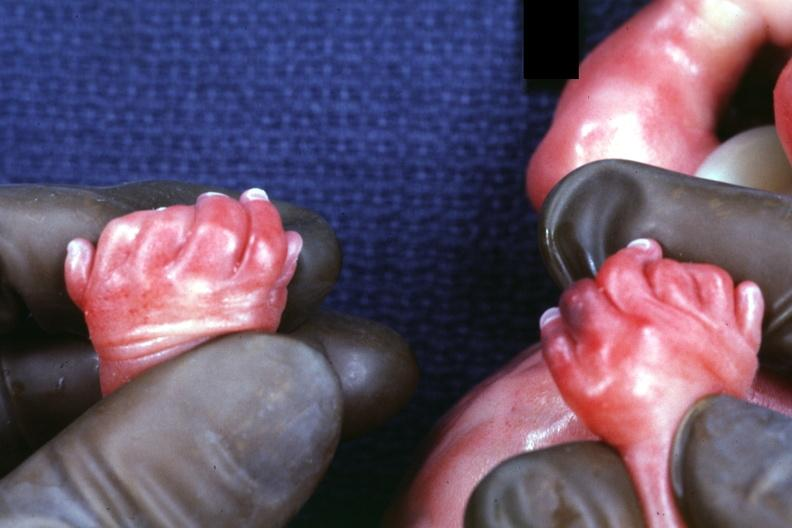re view looking down on heads present?
Answer the question using a single word or phrase. No 